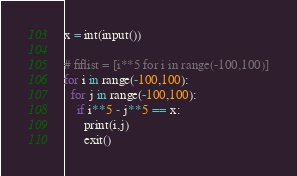<code> <loc_0><loc_0><loc_500><loc_500><_Python_>x = int(input())

# fiflist = [i**5 for i in range(-100,100)]
for i in range(-100,100):
  for j in range(-100,100):
    if i**5 - j**5 == x:
      print(i,j)
      exit()</code> 